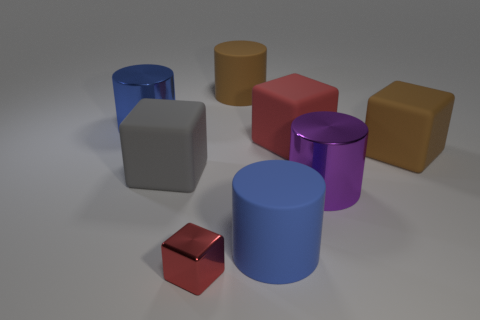Are there fewer metal things on the left side of the large brown cylinder than gray cylinders?
Offer a terse response. No. What is the shape of the red rubber object that is the same size as the purple thing?
Your answer should be compact. Cube. How many other things are the same color as the metallic cube?
Make the answer very short. 1. Do the purple cylinder and the blue metallic thing have the same size?
Keep it short and to the point. Yes. What number of objects are either large gray rubber objects or rubber things on the right side of the big brown matte cylinder?
Ensure brevity in your answer.  4. Are there fewer brown cylinders in front of the large gray cube than big metallic cylinders to the left of the large red cube?
Provide a succinct answer. Yes. What number of other things are the same material as the big brown cylinder?
Provide a short and direct response. 4. There is a large shiny cylinder that is on the left side of the tiny red shiny block; is it the same color as the tiny object?
Provide a short and direct response. No. There is a red cube behind the purple metallic thing; is there a big matte cylinder that is behind it?
Give a very brief answer. Yes. The thing that is both behind the purple cylinder and right of the red matte object is made of what material?
Give a very brief answer. Rubber. 